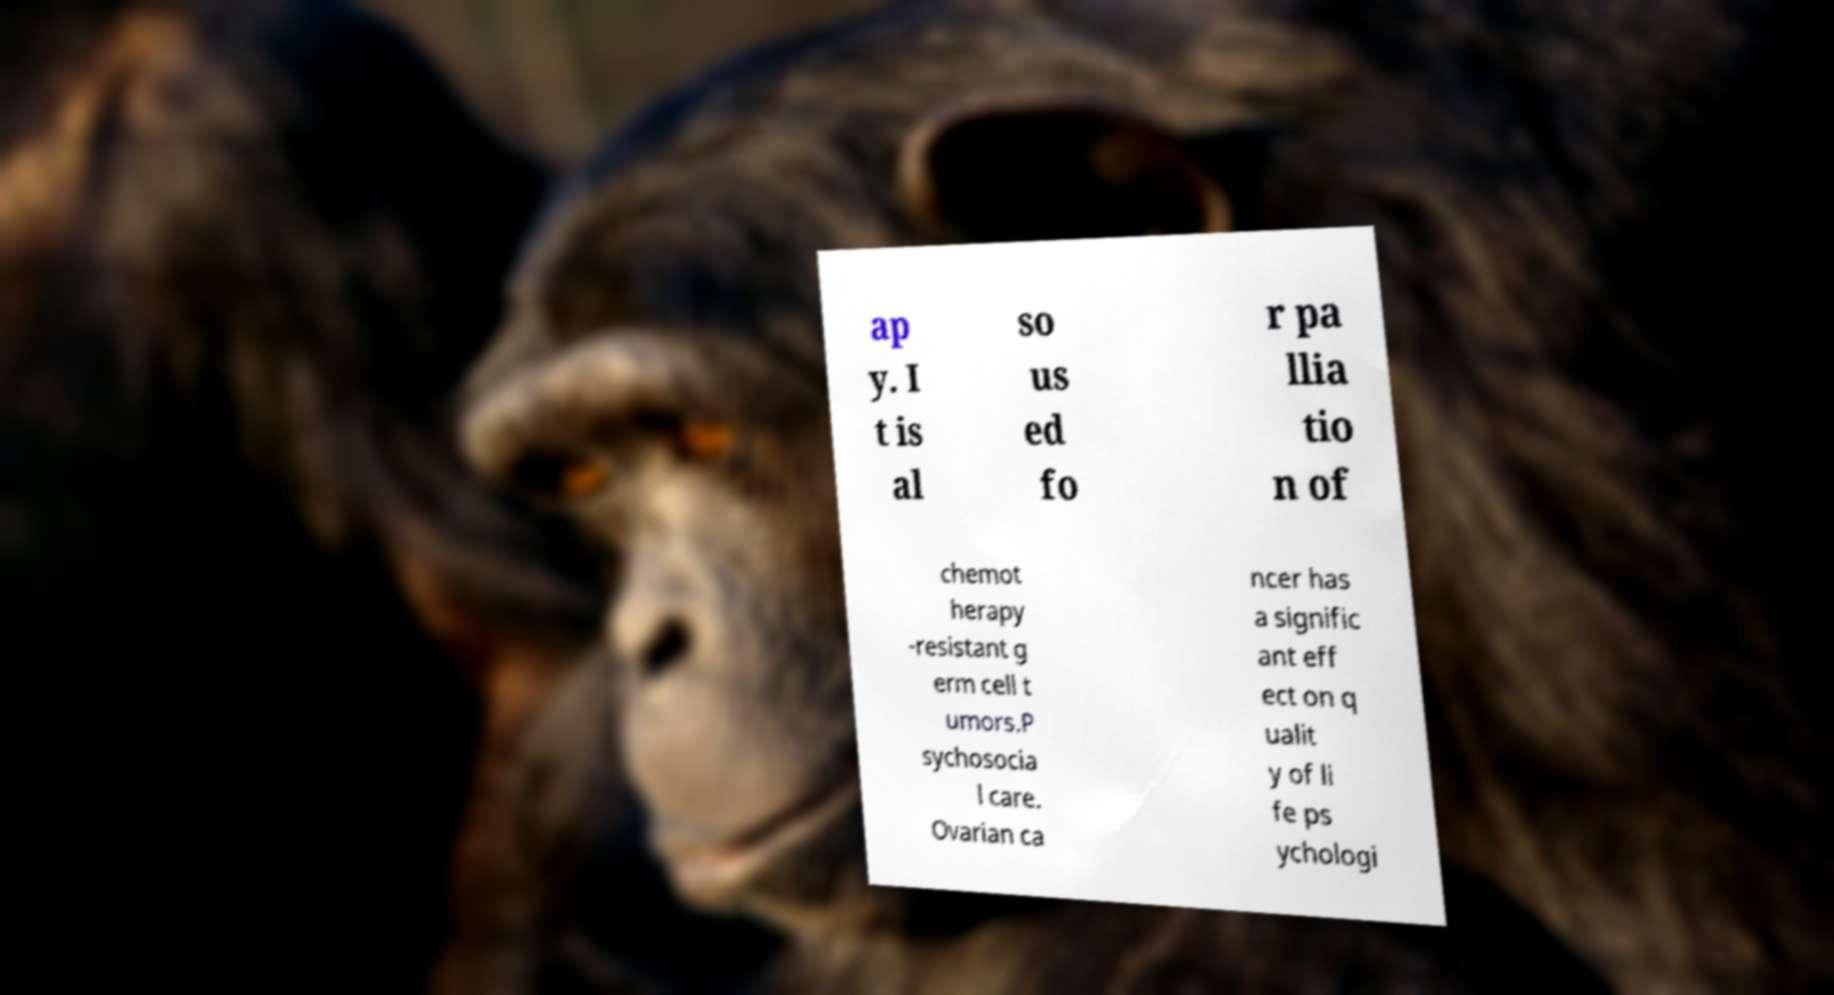For documentation purposes, I need the text within this image transcribed. Could you provide that? ap y. I t is al so us ed fo r pa llia tio n of chemot herapy -resistant g erm cell t umors.P sychosocia l care. Ovarian ca ncer has a signific ant eff ect on q ualit y of li fe ps ychologi 